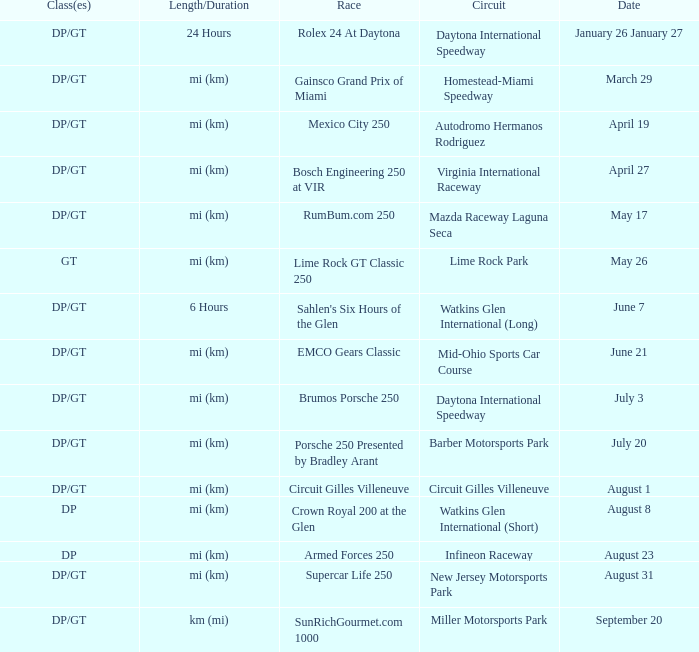Give me the full table as a dictionary. {'header': ['Class(es)', 'Length/Duration', 'Race', 'Circuit', 'Date'], 'rows': [['DP/GT', '24 Hours', 'Rolex 24 At Daytona', 'Daytona International Speedway', 'January 26 January 27'], ['DP/GT', 'mi (km)', 'Gainsco Grand Prix of Miami', 'Homestead-Miami Speedway', 'March 29'], ['DP/GT', 'mi (km)', 'Mexico City 250', 'Autodromo Hermanos Rodriguez', 'April 19'], ['DP/GT', 'mi (km)', 'Bosch Engineering 250 at VIR', 'Virginia International Raceway', 'April 27'], ['DP/GT', 'mi (km)', 'RumBum.com 250', 'Mazda Raceway Laguna Seca', 'May 17'], ['GT', 'mi (km)', 'Lime Rock GT Classic 250', 'Lime Rock Park', 'May 26'], ['DP/GT', '6 Hours', "Sahlen's Six Hours of the Glen", 'Watkins Glen International (Long)', 'June 7'], ['DP/GT', 'mi (km)', 'EMCO Gears Classic', 'Mid-Ohio Sports Car Course', 'June 21'], ['DP/GT', 'mi (km)', 'Brumos Porsche 250', 'Daytona International Speedway', 'July 3'], ['DP/GT', 'mi (km)', 'Porsche 250 Presented by Bradley Arant', 'Barber Motorsports Park', 'July 20'], ['DP/GT', 'mi (km)', 'Circuit Gilles Villeneuve', 'Circuit Gilles Villeneuve', 'August 1'], ['DP', 'mi (km)', 'Crown Royal 200 at the Glen', 'Watkins Glen International (Short)', 'August 8'], ['DP', 'mi (km)', 'Armed Forces 250', 'Infineon Raceway', 'August 23'], ['DP/GT', 'mi (km)', 'Supercar Life 250', 'New Jersey Motorsports Park', 'August 31'], ['DP/GT', 'km (mi)', 'SunRichGourmet.com 1000', 'Miller Motorsports Park', 'September 20']]} What are the classes for the circuit that has the Mazda Raceway Laguna Seca race. DP/GT. 